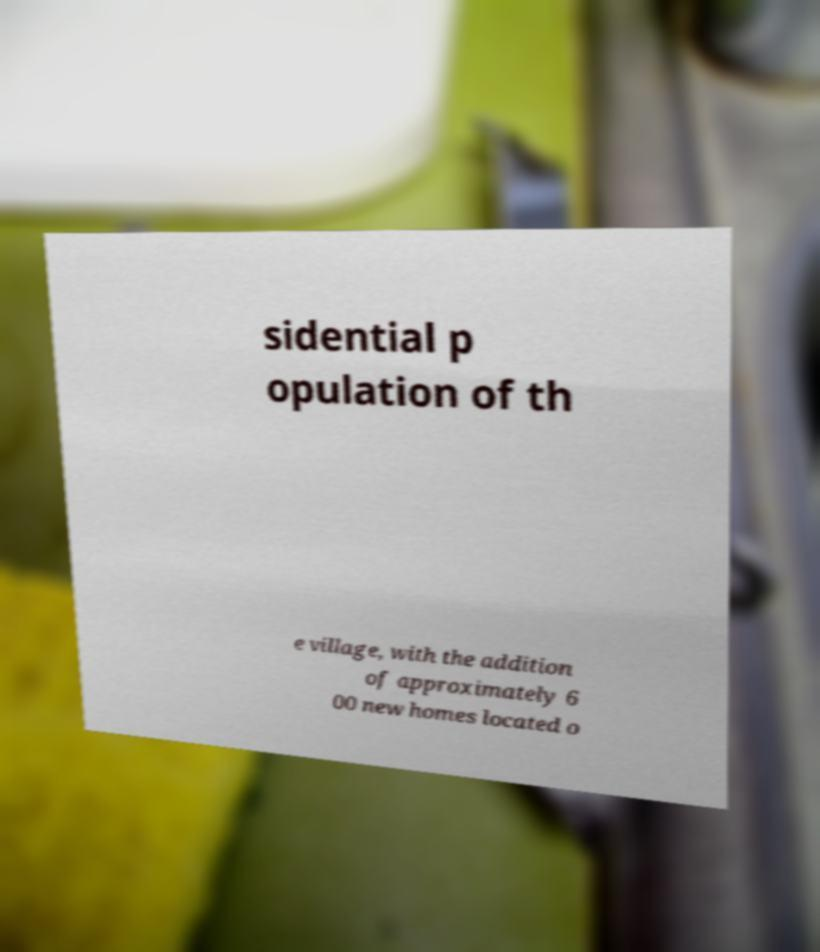Please read and relay the text visible in this image. What does it say? sidential p opulation of th e village, with the addition of approximately 6 00 new homes located o 